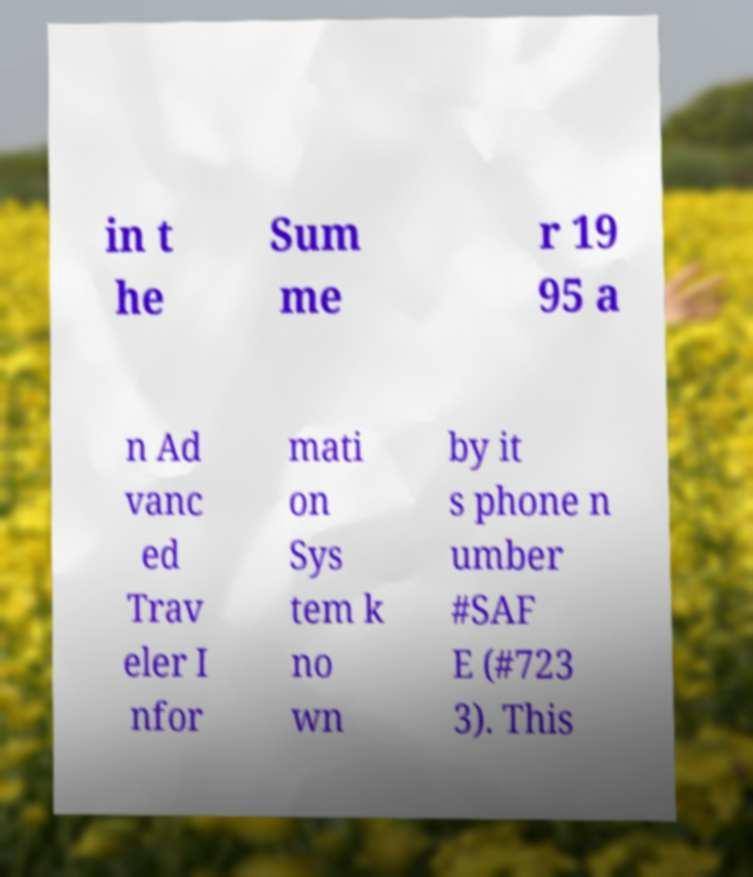Can you read and provide the text displayed in the image?This photo seems to have some interesting text. Can you extract and type it out for me? in t he Sum me r 19 95 a n Ad vanc ed Trav eler I nfor mati on Sys tem k no wn by it s phone n umber #SAF E (#723 3). This 